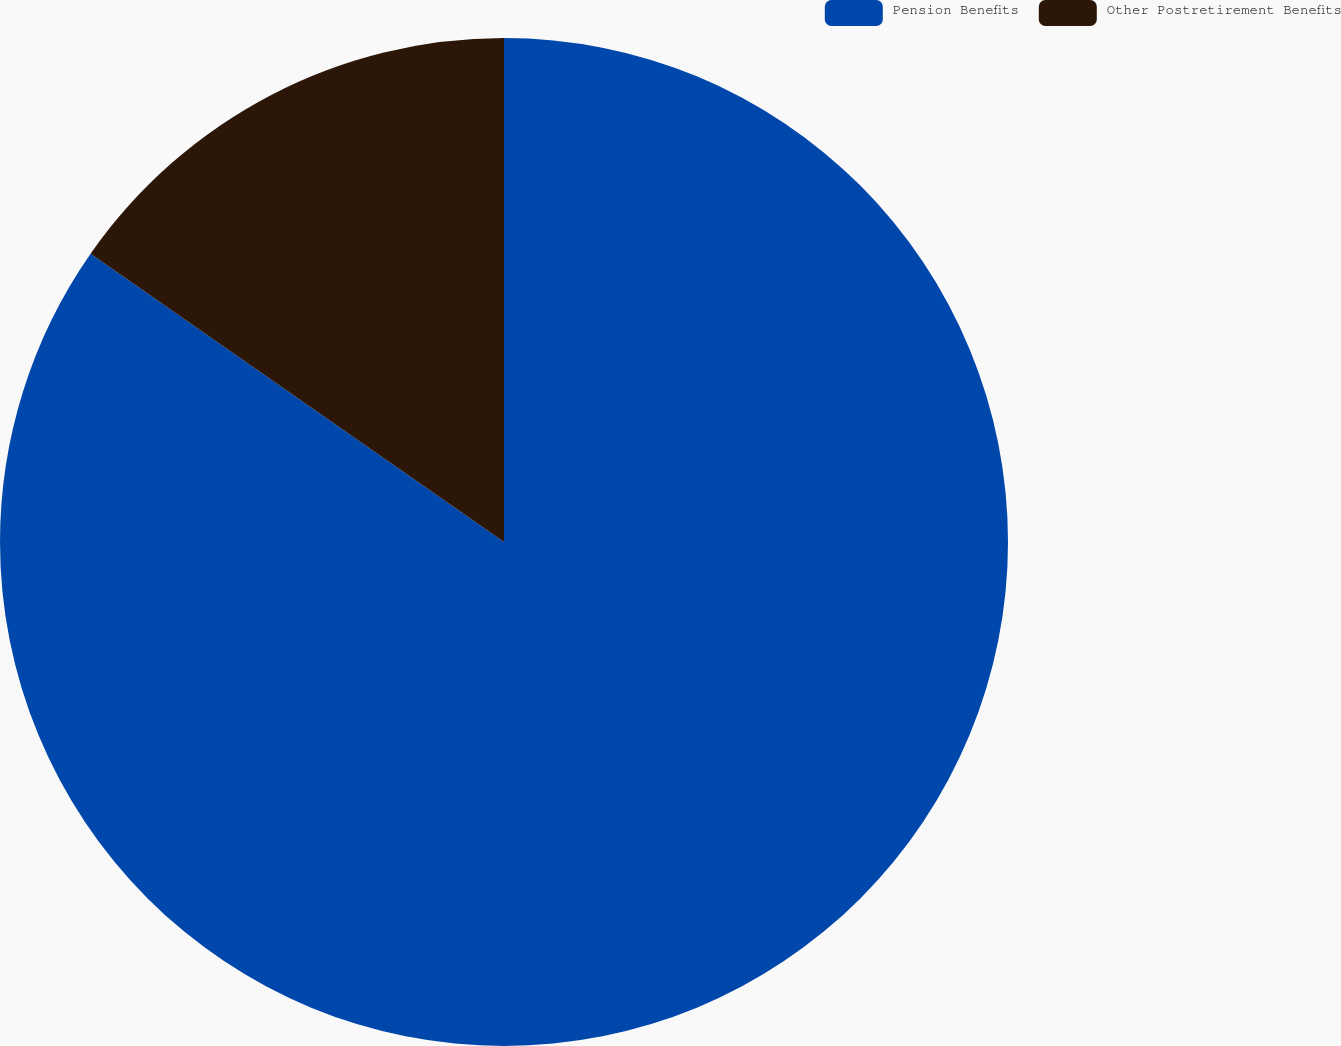<chart> <loc_0><loc_0><loc_500><loc_500><pie_chart><fcel>Pension Benefits<fcel>Other Postretirement Benefits<nl><fcel>84.69%<fcel>15.31%<nl></chart> 